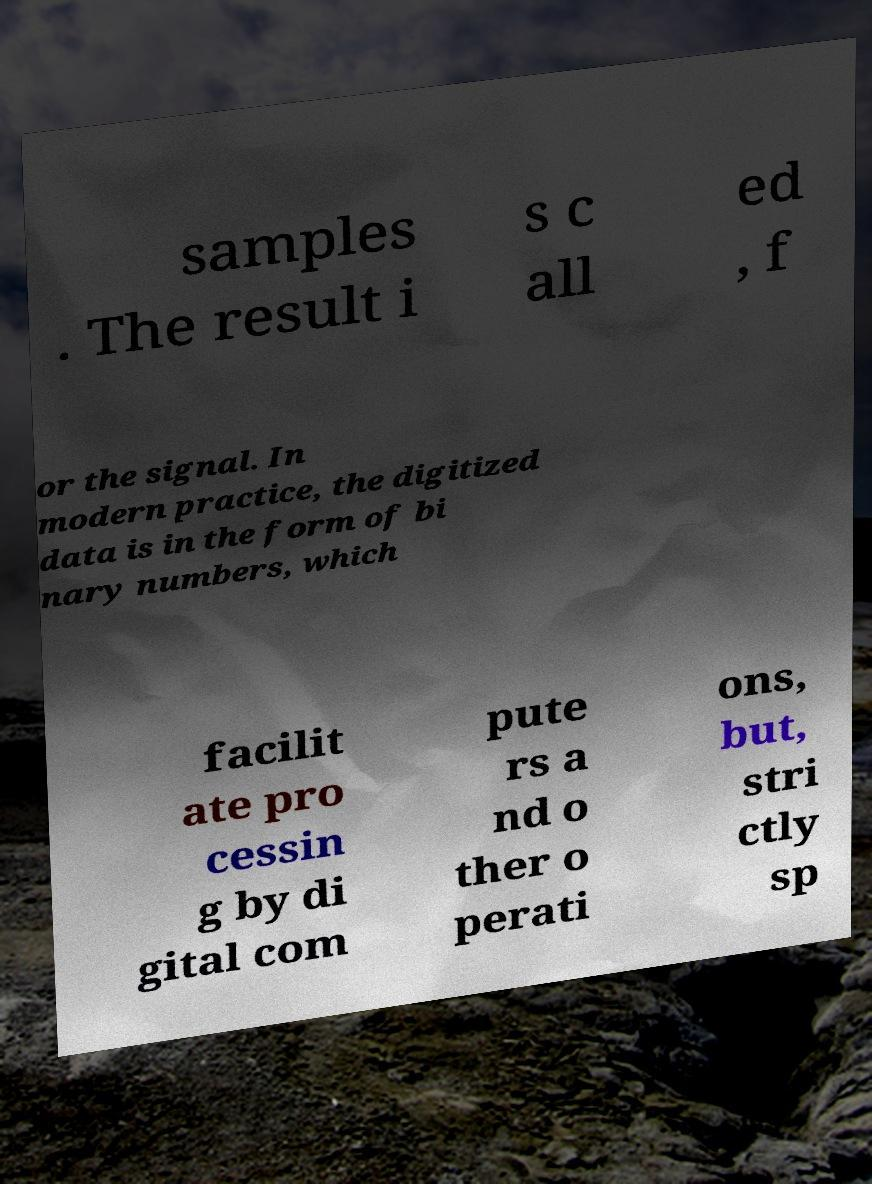Can you accurately transcribe the text from the provided image for me? samples . The result i s c all ed , f or the signal. In modern practice, the digitized data is in the form of bi nary numbers, which facilit ate pro cessin g by di gital com pute rs a nd o ther o perati ons, but, stri ctly sp 